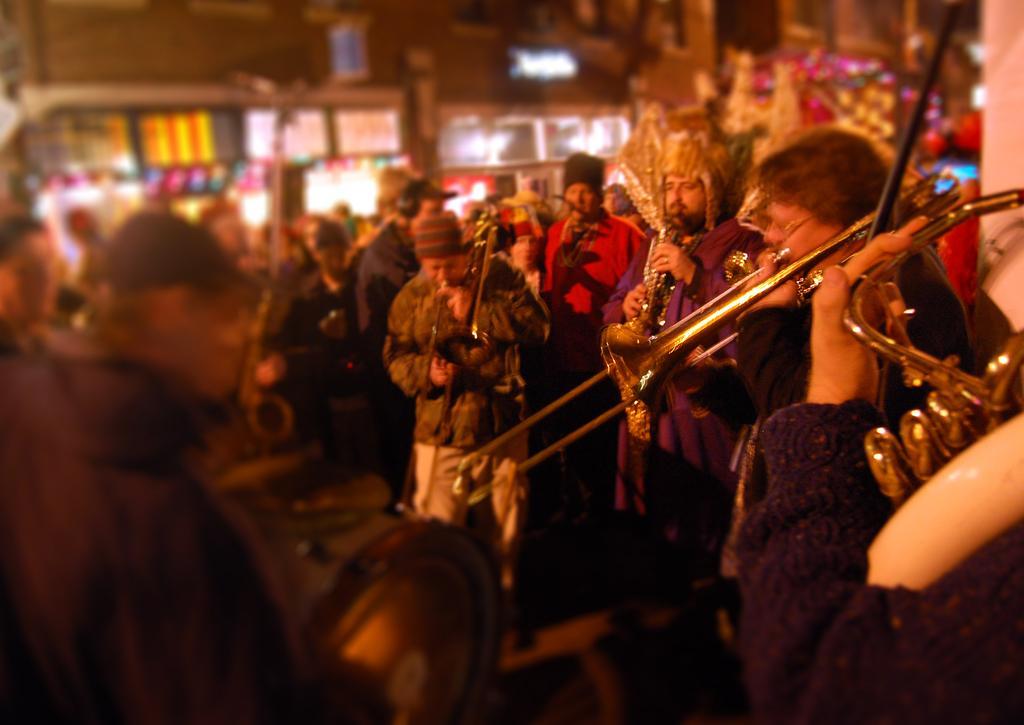In one or two sentences, can you explain what this image depicts? In this image people are playing musical instruments. Background it is blur. We can see stores. 